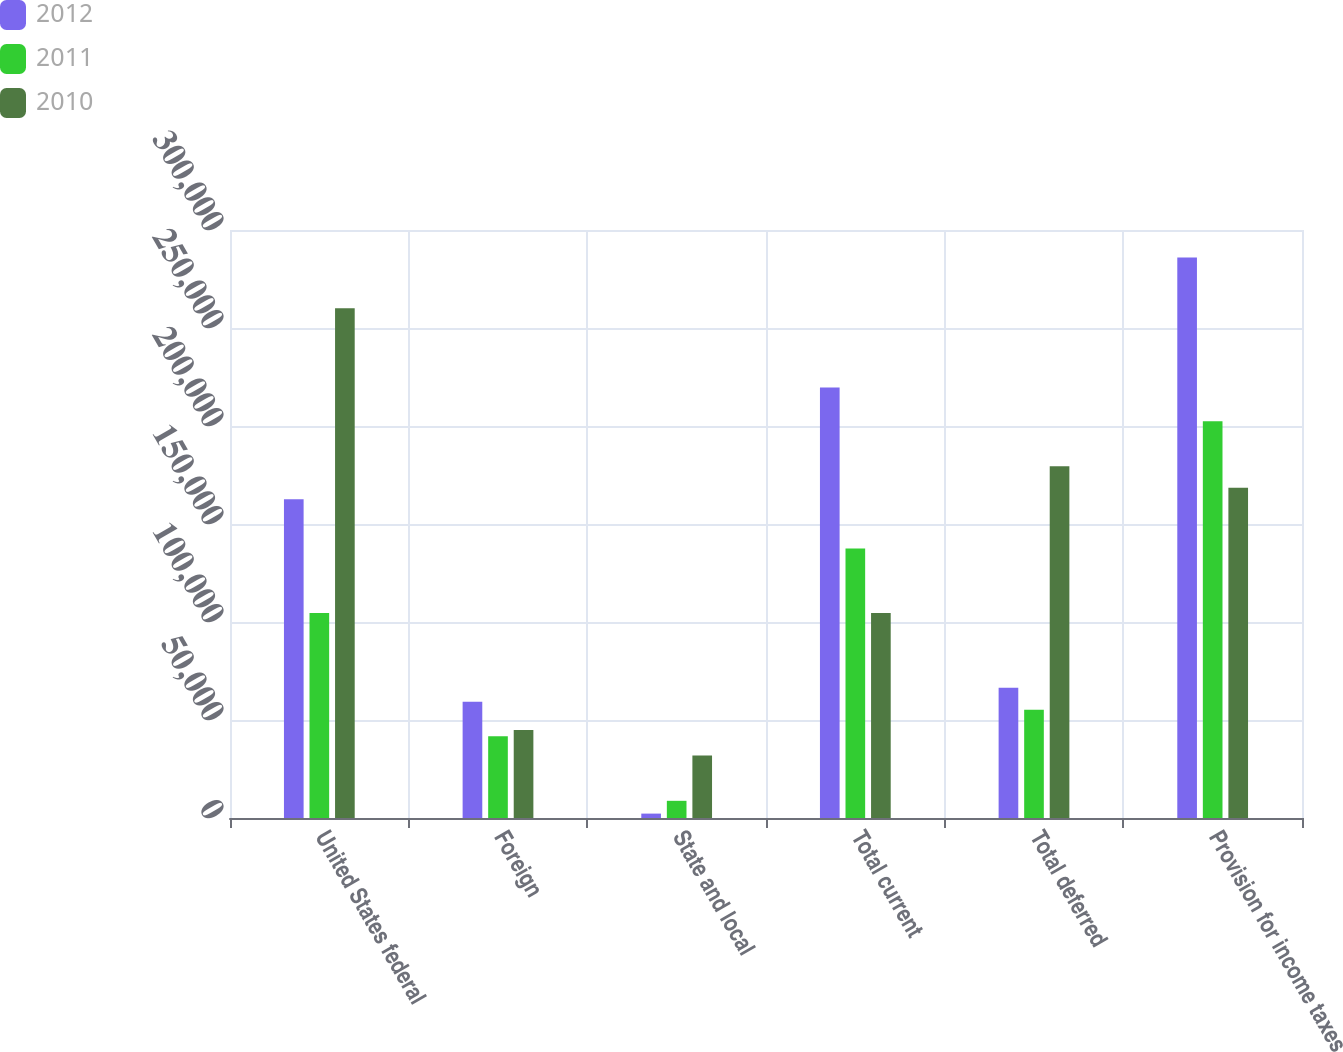Convert chart. <chart><loc_0><loc_0><loc_500><loc_500><stacked_bar_chart><ecel><fcel>United States federal<fcel>Foreign<fcel>State and local<fcel>Total current<fcel>Total deferred<fcel>Provision for income taxes<nl><fcel>2012<fcel>162574<fcel>59255<fcel>2244<fcel>219585<fcel>66434<fcel>286019<nl><fcel>2011<fcel>104587<fcel>41724<fcel>8769<fcel>137542<fcel>55273<fcel>202383<nl><fcel>2010<fcel>260118<fcel>44869<fcel>31866<fcel>104587<fcel>179490<fcel>168471<nl></chart> 